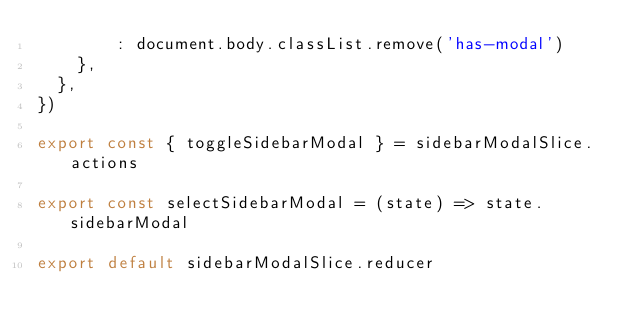<code> <loc_0><loc_0><loc_500><loc_500><_JavaScript_>        : document.body.classList.remove('has-modal')
    },
  },
})

export const { toggleSidebarModal } = sidebarModalSlice.actions

export const selectSidebarModal = (state) => state.sidebarModal

export default sidebarModalSlice.reducer
</code> 